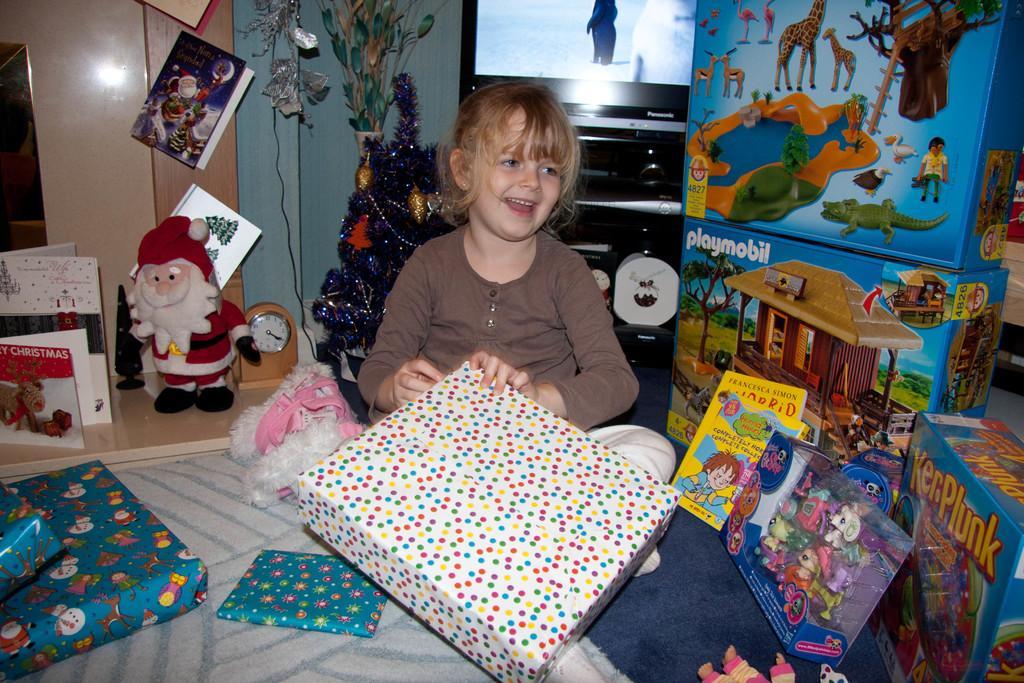Describe this image in one or two sentences. In this picture I can see a girl sitting on the bed holding a gift box. I can see some objects on the left-hand side and right-hand side. I can see television in the background. 